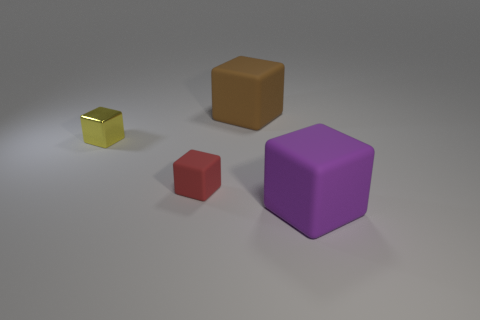Does the purple rubber object have the same shape as the big brown object?
Your answer should be compact. Yes. How many things are either tiny objects that are right of the metal block or small things?
Your answer should be compact. 2. Is there another tiny red rubber thing that has the same shape as the red rubber object?
Offer a terse response. No. Are there an equal number of red cubes behind the large brown rubber cube and big purple matte cylinders?
Ensure brevity in your answer.  Yes. How many brown matte things are the same size as the purple rubber cube?
Make the answer very short. 1. How many yellow metal objects are in front of the big brown rubber object?
Your answer should be very brief. 1. The big cube to the right of the large matte cube that is on the left side of the purple matte thing is made of what material?
Provide a short and direct response. Rubber. There is a red cube that is the same material as the big brown thing; what is its size?
Make the answer very short. Small. There is a tiny thing behind the tiny red block; what is its color?
Offer a very short reply. Yellow. Are there any blocks that are in front of the small red thing that is left of the matte object that is behind the small yellow shiny thing?
Keep it short and to the point. Yes. 